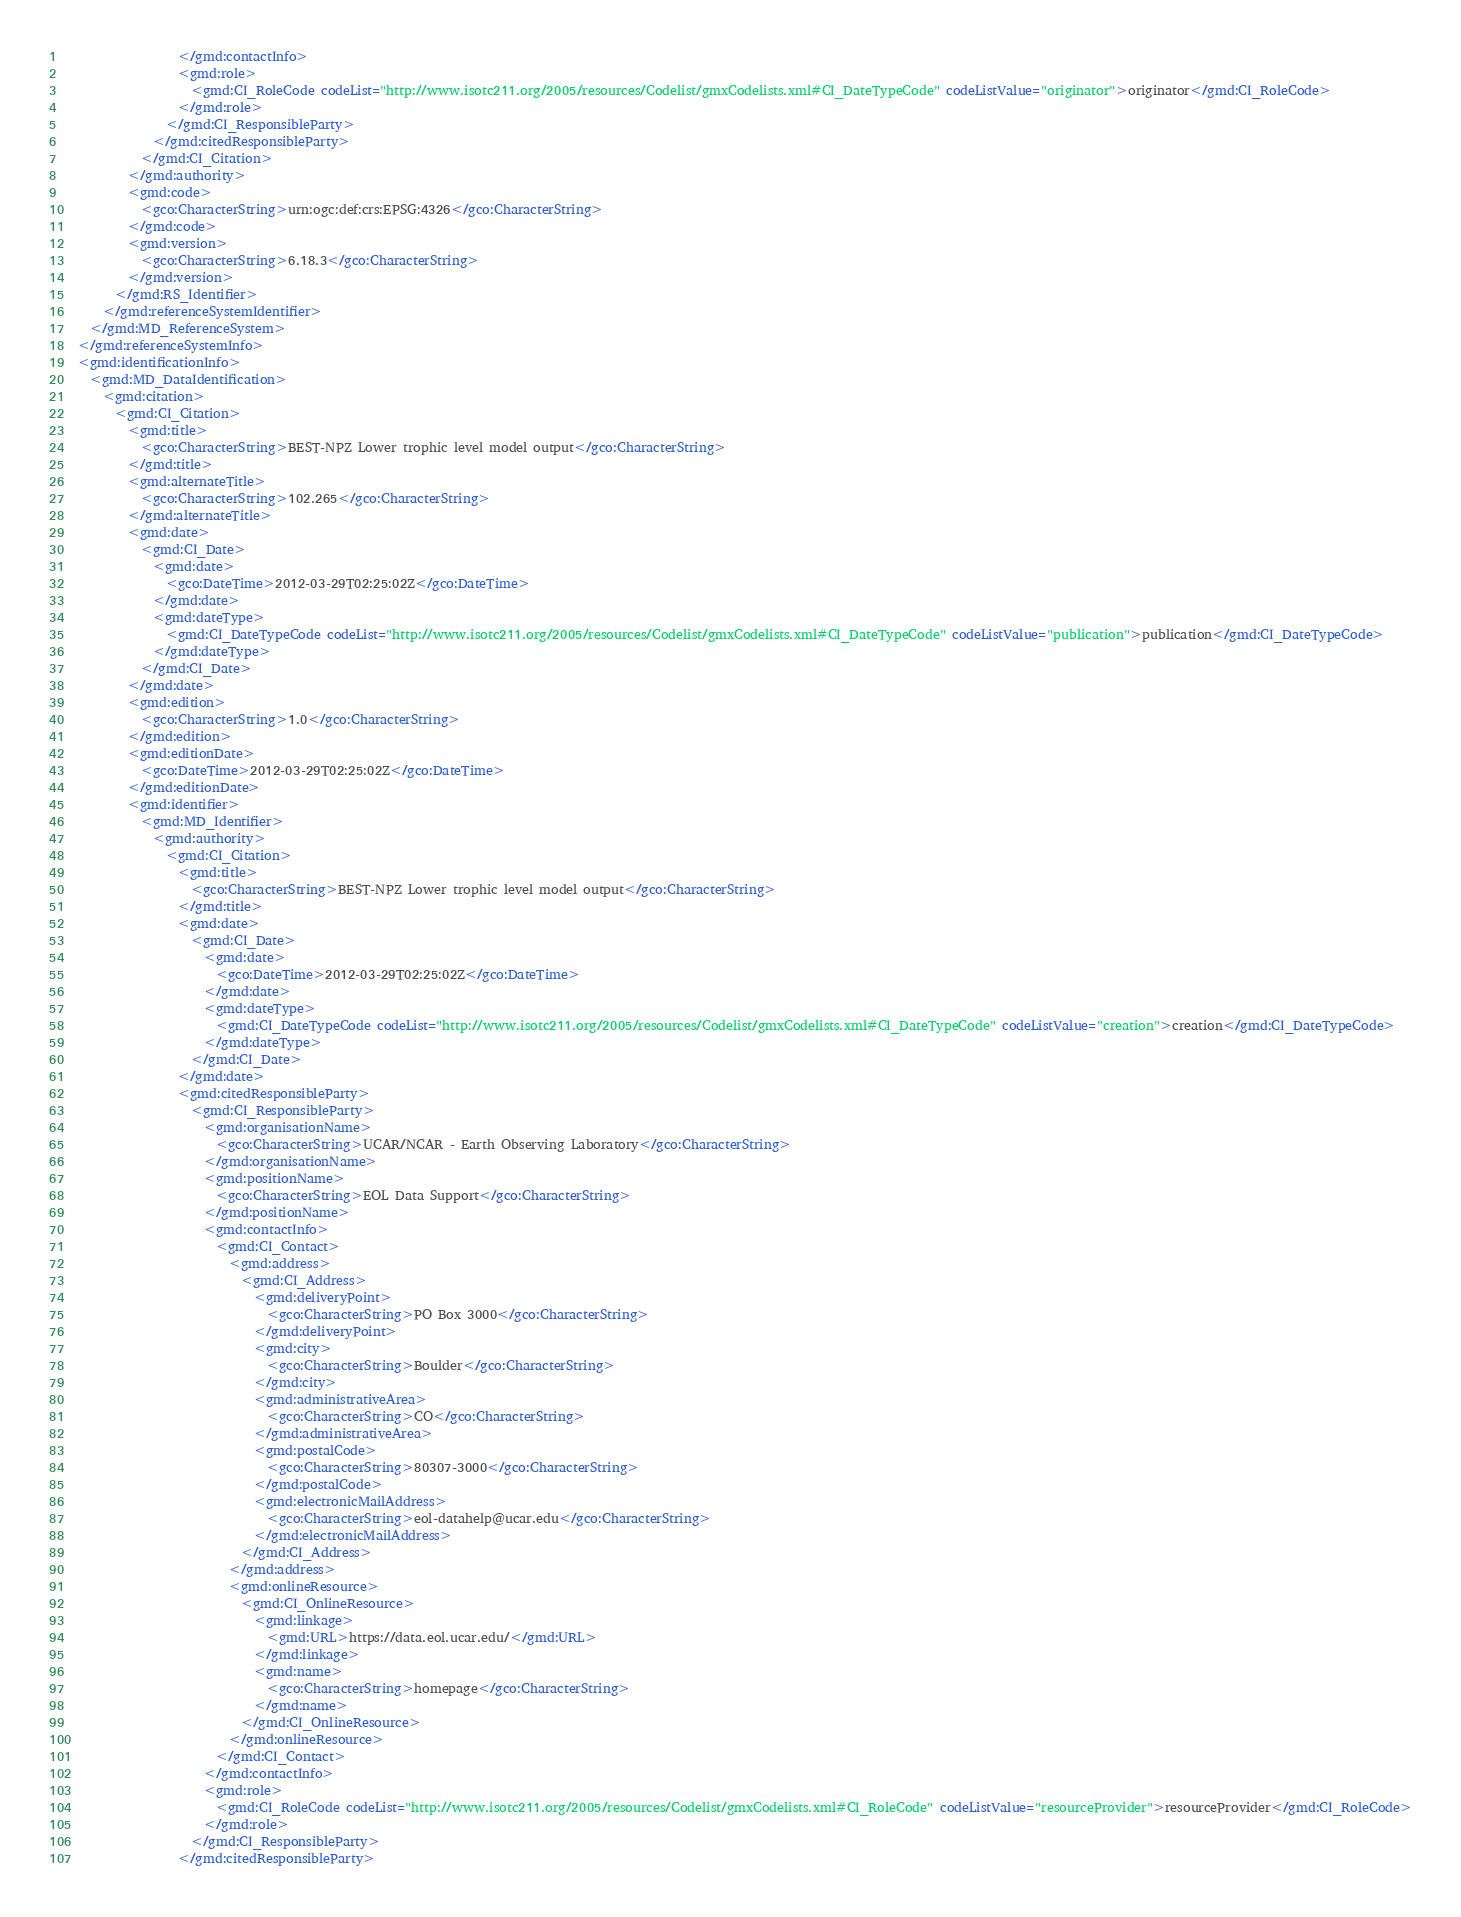<code> <loc_0><loc_0><loc_500><loc_500><_XML_>                  </gmd:contactInfo>
                  <gmd:role>
                    <gmd:CI_RoleCode codeList="http://www.isotc211.org/2005/resources/Codelist/gmxCodelists.xml#CI_DateTypeCode" codeListValue="originator">originator</gmd:CI_RoleCode>
                  </gmd:role>
                </gmd:CI_ResponsibleParty>
              </gmd:citedResponsibleParty>
            </gmd:CI_Citation>
          </gmd:authority>
          <gmd:code>
            <gco:CharacterString>urn:ogc:def:crs:EPSG:4326</gco:CharacterString>
          </gmd:code>
          <gmd:version>
            <gco:CharacterString>6.18.3</gco:CharacterString>
          </gmd:version>
        </gmd:RS_Identifier>
      </gmd:referenceSystemIdentifier>
    </gmd:MD_ReferenceSystem>
  </gmd:referenceSystemInfo>
  <gmd:identificationInfo>
    <gmd:MD_DataIdentification>
      <gmd:citation>
        <gmd:CI_Citation>
          <gmd:title>
            <gco:CharacterString>BEST-NPZ Lower trophic level model output</gco:CharacterString>
          </gmd:title>
          <gmd:alternateTitle>
            <gco:CharacterString>102.265</gco:CharacterString>
          </gmd:alternateTitle>
          <gmd:date>
            <gmd:CI_Date>
              <gmd:date>
                <gco:DateTime>2012-03-29T02:25:02Z</gco:DateTime>
              </gmd:date>
              <gmd:dateType>
                <gmd:CI_DateTypeCode codeList="http://www.isotc211.org/2005/resources/Codelist/gmxCodelists.xml#CI_DateTypeCode" codeListValue="publication">publication</gmd:CI_DateTypeCode>
              </gmd:dateType>
            </gmd:CI_Date>
          </gmd:date>
          <gmd:edition>
            <gco:CharacterString>1.0</gco:CharacterString>
          </gmd:edition>
          <gmd:editionDate>
            <gco:DateTime>2012-03-29T02:25:02Z</gco:DateTime>
          </gmd:editionDate>
          <gmd:identifier>
            <gmd:MD_Identifier>
              <gmd:authority>
                <gmd:CI_Citation>
                  <gmd:title>
                    <gco:CharacterString>BEST-NPZ Lower trophic level model output</gco:CharacterString>
                  </gmd:title>
                  <gmd:date>
                    <gmd:CI_Date>
                      <gmd:date>
                        <gco:DateTime>2012-03-29T02:25:02Z</gco:DateTime>
                      </gmd:date>
                      <gmd:dateType>
                        <gmd:CI_DateTypeCode codeList="http://www.isotc211.org/2005/resources/Codelist/gmxCodelists.xml#CI_DateTypeCode" codeListValue="creation">creation</gmd:CI_DateTypeCode>
                      </gmd:dateType>
                    </gmd:CI_Date>
                  </gmd:date>
                  <gmd:citedResponsibleParty>
                    <gmd:CI_ResponsibleParty>
                      <gmd:organisationName>
                        <gco:CharacterString>UCAR/NCAR - Earth Observing Laboratory</gco:CharacterString>
                      </gmd:organisationName>
                      <gmd:positionName>
                        <gco:CharacterString>EOL Data Support</gco:CharacterString>
                      </gmd:positionName>
                      <gmd:contactInfo>
                        <gmd:CI_Contact>
                          <gmd:address>
                            <gmd:CI_Address>
                              <gmd:deliveryPoint>
                                <gco:CharacterString>PO Box 3000</gco:CharacterString>
                              </gmd:deliveryPoint>
                              <gmd:city>
                                <gco:CharacterString>Boulder</gco:CharacterString>
                              </gmd:city>
                              <gmd:administrativeArea>
                                <gco:CharacterString>CO</gco:CharacterString>
                              </gmd:administrativeArea>
                              <gmd:postalCode>
                                <gco:CharacterString>80307-3000</gco:CharacterString>
                              </gmd:postalCode>
                              <gmd:electronicMailAddress>
                                <gco:CharacterString>eol-datahelp@ucar.edu</gco:CharacterString>
                              </gmd:electronicMailAddress>
                            </gmd:CI_Address>
                          </gmd:address>
                          <gmd:onlineResource>
                            <gmd:CI_OnlineResource>
                              <gmd:linkage>
                                <gmd:URL>https://data.eol.ucar.edu/</gmd:URL>
                              </gmd:linkage>
                              <gmd:name>
                                <gco:CharacterString>homepage</gco:CharacterString>
                              </gmd:name>
                            </gmd:CI_OnlineResource>
                          </gmd:onlineResource>
                        </gmd:CI_Contact>
                      </gmd:contactInfo>
                      <gmd:role>
                        <gmd:CI_RoleCode codeList="http://www.isotc211.org/2005/resources/Codelist/gmxCodelists.xml#CI_RoleCode" codeListValue="resourceProvider">resourceProvider</gmd:CI_RoleCode>
                      </gmd:role>
                    </gmd:CI_ResponsibleParty>
                  </gmd:citedResponsibleParty></code> 